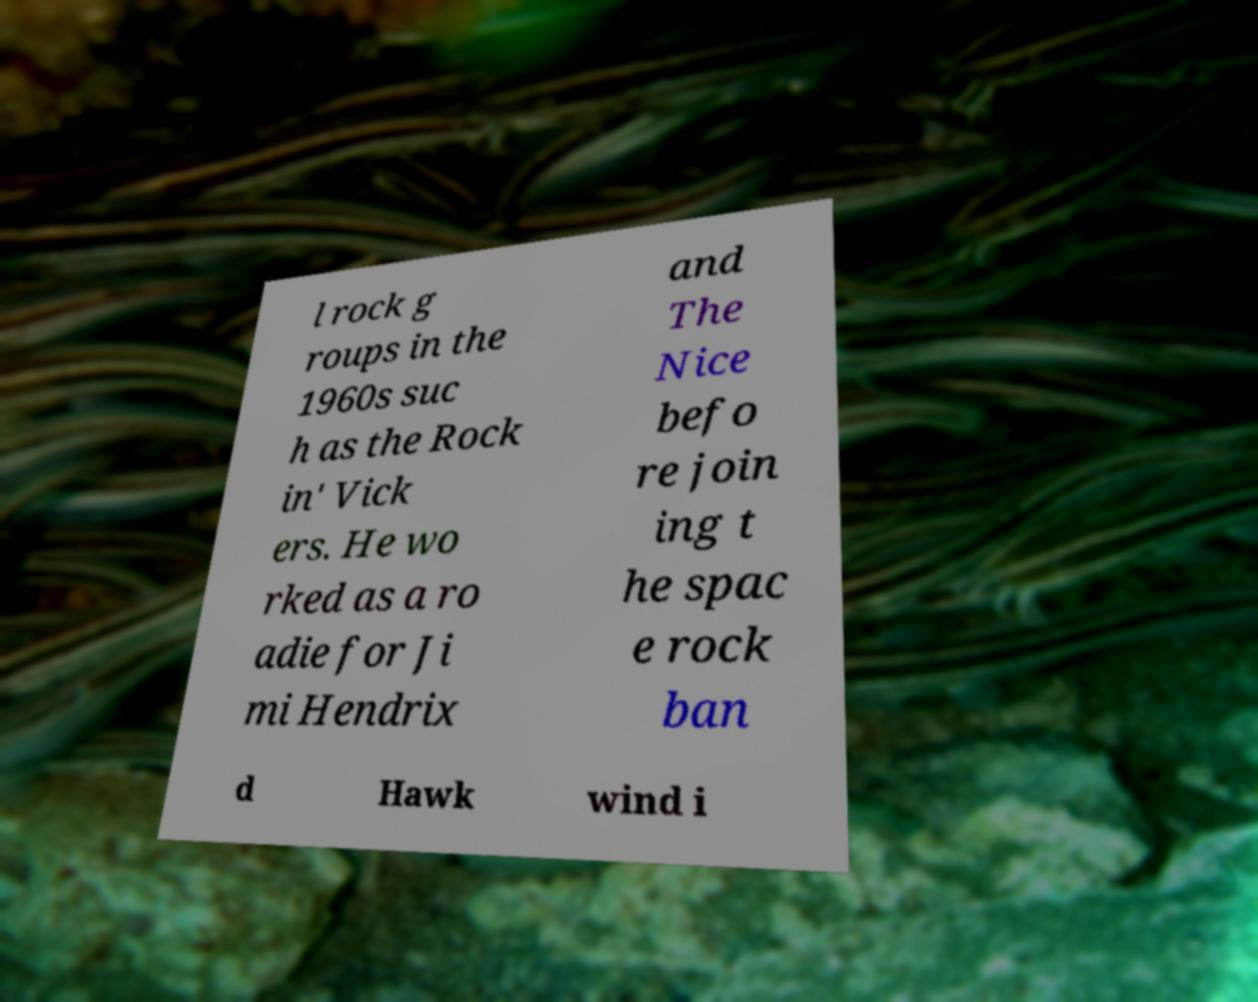Can you accurately transcribe the text from the provided image for me? l rock g roups in the 1960s suc h as the Rock in' Vick ers. He wo rked as a ro adie for Ji mi Hendrix and The Nice befo re join ing t he spac e rock ban d Hawk wind i 